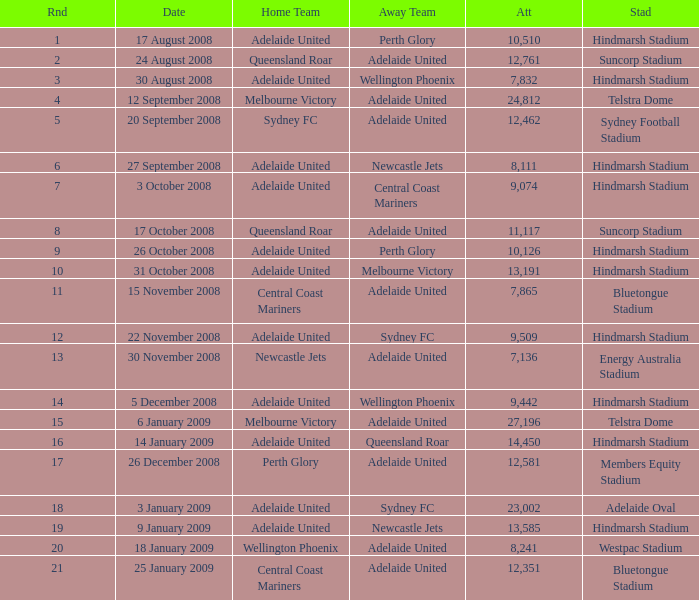Who was the away team when Queensland Roar was the home team in the round less than 3? Adelaide United. 